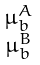<formula> <loc_0><loc_0><loc_500><loc_500>\begin{smallmatrix} \mu _ { b } ^ { A } \\ \mu _ { b } ^ { B } \end{smallmatrix}</formula> 